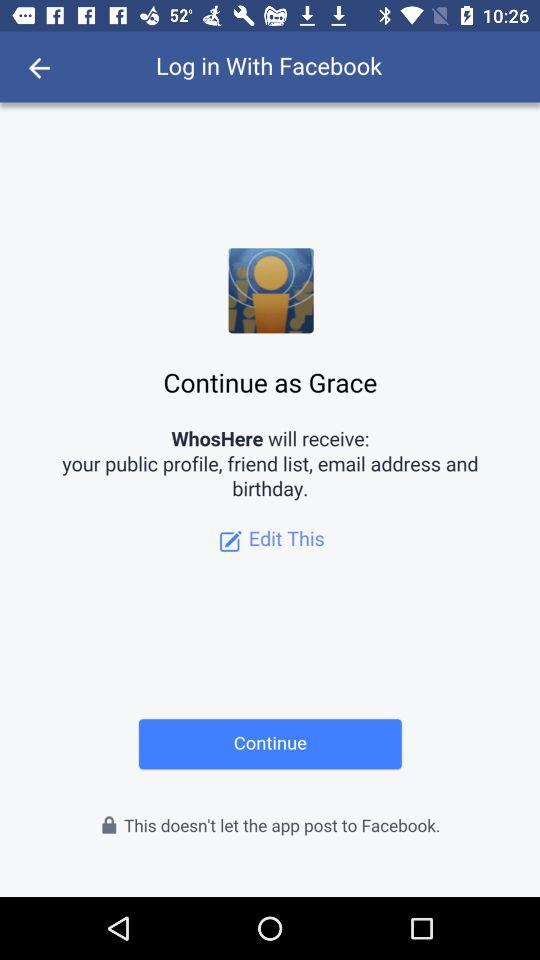What is the user name to continue on the login page? The user name to continue on the login page is Grace. 